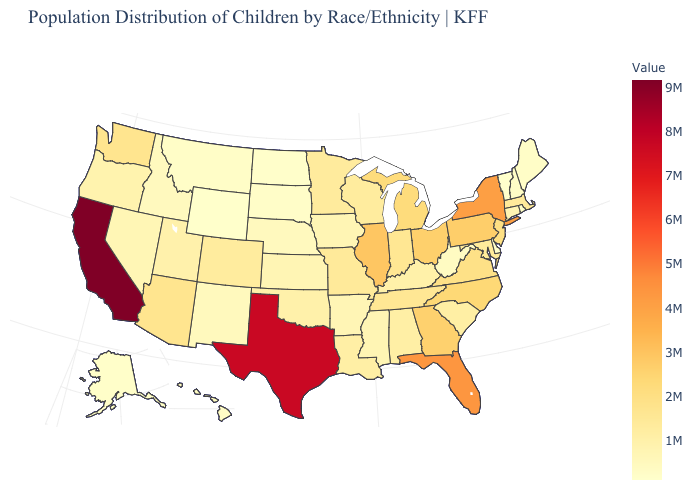Among the states that border Ohio , does West Virginia have the lowest value?
Give a very brief answer. Yes. Does Alaska have the highest value in the West?
Give a very brief answer. No. Which states have the highest value in the USA?
Keep it brief. California. Among the states that border Mississippi , does Tennessee have the highest value?
Answer briefly. Yes. Which states hav the highest value in the West?
Give a very brief answer. California. Among the states that border West Virginia , does Ohio have the highest value?
Write a very short answer. No. 